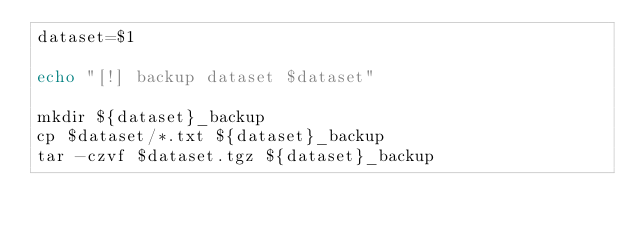Convert code to text. <code><loc_0><loc_0><loc_500><loc_500><_Bash_>dataset=$1

echo "[!] backup dataset $dataset"

mkdir ${dataset}_backup
cp $dataset/*.txt ${dataset}_backup
tar -czvf $dataset.tgz ${dataset}_backup
</code> 